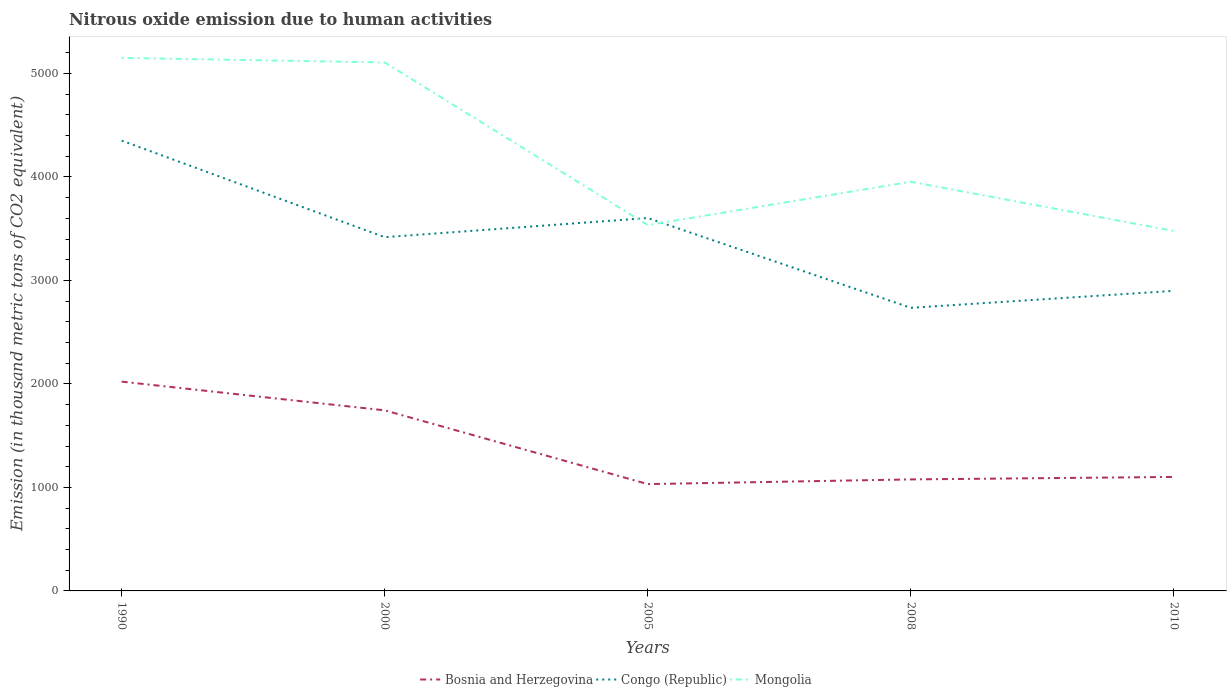How many different coloured lines are there?
Offer a very short reply. 3. Does the line corresponding to Bosnia and Herzegovina intersect with the line corresponding to Congo (Republic)?
Give a very brief answer. No. Is the number of lines equal to the number of legend labels?
Give a very brief answer. Yes. Across all years, what is the maximum amount of nitrous oxide emitted in Bosnia and Herzegovina?
Your answer should be compact. 1032.3. In which year was the amount of nitrous oxide emitted in Mongolia maximum?
Give a very brief answer. 2010. What is the total amount of nitrous oxide emitted in Bosnia and Herzegovina in the graph?
Ensure brevity in your answer.  712.6. What is the difference between the highest and the second highest amount of nitrous oxide emitted in Mongolia?
Your answer should be compact. 1672.8. Is the amount of nitrous oxide emitted in Bosnia and Herzegovina strictly greater than the amount of nitrous oxide emitted in Congo (Republic) over the years?
Offer a terse response. Yes. How many lines are there?
Your answer should be very brief. 3. How many years are there in the graph?
Make the answer very short. 5. What is the difference between two consecutive major ticks on the Y-axis?
Your answer should be compact. 1000. Does the graph contain grids?
Provide a short and direct response. No. What is the title of the graph?
Provide a succinct answer. Nitrous oxide emission due to human activities. What is the label or title of the X-axis?
Offer a terse response. Years. What is the label or title of the Y-axis?
Give a very brief answer. Emission (in thousand metric tons of CO2 equivalent). What is the Emission (in thousand metric tons of CO2 equivalent) in Bosnia and Herzegovina in 1990?
Offer a terse response. 2022.6. What is the Emission (in thousand metric tons of CO2 equivalent) in Congo (Republic) in 1990?
Keep it short and to the point. 4351.5. What is the Emission (in thousand metric tons of CO2 equivalent) in Mongolia in 1990?
Provide a short and direct response. 5151. What is the Emission (in thousand metric tons of CO2 equivalent) of Bosnia and Herzegovina in 2000?
Your answer should be very brief. 1744.9. What is the Emission (in thousand metric tons of CO2 equivalent) in Congo (Republic) in 2000?
Ensure brevity in your answer.  3418.3. What is the Emission (in thousand metric tons of CO2 equivalent) of Mongolia in 2000?
Give a very brief answer. 5106.8. What is the Emission (in thousand metric tons of CO2 equivalent) of Bosnia and Herzegovina in 2005?
Keep it short and to the point. 1032.3. What is the Emission (in thousand metric tons of CO2 equivalent) in Congo (Republic) in 2005?
Your answer should be compact. 3603.5. What is the Emission (in thousand metric tons of CO2 equivalent) in Mongolia in 2005?
Ensure brevity in your answer.  3535.4. What is the Emission (in thousand metric tons of CO2 equivalent) in Bosnia and Herzegovina in 2008?
Your answer should be compact. 1077.6. What is the Emission (in thousand metric tons of CO2 equivalent) in Congo (Republic) in 2008?
Offer a terse response. 2735.8. What is the Emission (in thousand metric tons of CO2 equivalent) in Mongolia in 2008?
Give a very brief answer. 3953.8. What is the Emission (in thousand metric tons of CO2 equivalent) of Bosnia and Herzegovina in 2010?
Keep it short and to the point. 1101.5. What is the Emission (in thousand metric tons of CO2 equivalent) of Congo (Republic) in 2010?
Give a very brief answer. 2899.8. What is the Emission (in thousand metric tons of CO2 equivalent) of Mongolia in 2010?
Your answer should be very brief. 3478.2. Across all years, what is the maximum Emission (in thousand metric tons of CO2 equivalent) of Bosnia and Herzegovina?
Provide a short and direct response. 2022.6. Across all years, what is the maximum Emission (in thousand metric tons of CO2 equivalent) in Congo (Republic)?
Your answer should be compact. 4351.5. Across all years, what is the maximum Emission (in thousand metric tons of CO2 equivalent) of Mongolia?
Your answer should be very brief. 5151. Across all years, what is the minimum Emission (in thousand metric tons of CO2 equivalent) in Bosnia and Herzegovina?
Offer a terse response. 1032.3. Across all years, what is the minimum Emission (in thousand metric tons of CO2 equivalent) in Congo (Republic)?
Your response must be concise. 2735.8. Across all years, what is the minimum Emission (in thousand metric tons of CO2 equivalent) of Mongolia?
Make the answer very short. 3478.2. What is the total Emission (in thousand metric tons of CO2 equivalent) of Bosnia and Herzegovina in the graph?
Make the answer very short. 6978.9. What is the total Emission (in thousand metric tons of CO2 equivalent) of Congo (Republic) in the graph?
Make the answer very short. 1.70e+04. What is the total Emission (in thousand metric tons of CO2 equivalent) of Mongolia in the graph?
Your answer should be very brief. 2.12e+04. What is the difference between the Emission (in thousand metric tons of CO2 equivalent) of Bosnia and Herzegovina in 1990 and that in 2000?
Provide a short and direct response. 277.7. What is the difference between the Emission (in thousand metric tons of CO2 equivalent) in Congo (Republic) in 1990 and that in 2000?
Your answer should be very brief. 933.2. What is the difference between the Emission (in thousand metric tons of CO2 equivalent) of Mongolia in 1990 and that in 2000?
Make the answer very short. 44.2. What is the difference between the Emission (in thousand metric tons of CO2 equivalent) of Bosnia and Herzegovina in 1990 and that in 2005?
Offer a very short reply. 990.3. What is the difference between the Emission (in thousand metric tons of CO2 equivalent) in Congo (Republic) in 1990 and that in 2005?
Offer a terse response. 748. What is the difference between the Emission (in thousand metric tons of CO2 equivalent) of Mongolia in 1990 and that in 2005?
Your answer should be compact. 1615.6. What is the difference between the Emission (in thousand metric tons of CO2 equivalent) of Bosnia and Herzegovina in 1990 and that in 2008?
Your answer should be very brief. 945. What is the difference between the Emission (in thousand metric tons of CO2 equivalent) in Congo (Republic) in 1990 and that in 2008?
Provide a short and direct response. 1615.7. What is the difference between the Emission (in thousand metric tons of CO2 equivalent) in Mongolia in 1990 and that in 2008?
Your response must be concise. 1197.2. What is the difference between the Emission (in thousand metric tons of CO2 equivalent) of Bosnia and Herzegovina in 1990 and that in 2010?
Provide a succinct answer. 921.1. What is the difference between the Emission (in thousand metric tons of CO2 equivalent) in Congo (Republic) in 1990 and that in 2010?
Your answer should be compact. 1451.7. What is the difference between the Emission (in thousand metric tons of CO2 equivalent) in Mongolia in 1990 and that in 2010?
Provide a succinct answer. 1672.8. What is the difference between the Emission (in thousand metric tons of CO2 equivalent) of Bosnia and Herzegovina in 2000 and that in 2005?
Give a very brief answer. 712.6. What is the difference between the Emission (in thousand metric tons of CO2 equivalent) of Congo (Republic) in 2000 and that in 2005?
Give a very brief answer. -185.2. What is the difference between the Emission (in thousand metric tons of CO2 equivalent) of Mongolia in 2000 and that in 2005?
Your answer should be very brief. 1571.4. What is the difference between the Emission (in thousand metric tons of CO2 equivalent) of Bosnia and Herzegovina in 2000 and that in 2008?
Offer a very short reply. 667.3. What is the difference between the Emission (in thousand metric tons of CO2 equivalent) of Congo (Republic) in 2000 and that in 2008?
Ensure brevity in your answer.  682.5. What is the difference between the Emission (in thousand metric tons of CO2 equivalent) of Mongolia in 2000 and that in 2008?
Your response must be concise. 1153. What is the difference between the Emission (in thousand metric tons of CO2 equivalent) of Bosnia and Herzegovina in 2000 and that in 2010?
Offer a very short reply. 643.4. What is the difference between the Emission (in thousand metric tons of CO2 equivalent) in Congo (Republic) in 2000 and that in 2010?
Give a very brief answer. 518.5. What is the difference between the Emission (in thousand metric tons of CO2 equivalent) in Mongolia in 2000 and that in 2010?
Your answer should be compact. 1628.6. What is the difference between the Emission (in thousand metric tons of CO2 equivalent) of Bosnia and Herzegovina in 2005 and that in 2008?
Keep it short and to the point. -45.3. What is the difference between the Emission (in thousand metric tons of CO2 equivalent) in Congo (Republic) in 2005 and that in 2008?
Your response must be concise. 867.7. What is the difference between the Emission (in thousand metric tons of CO2 equivalent) of Mongolia in 2005 and that in 2008?
Ensure brevity in your answer.  -418.4. What is the difference between the Emission (in thousand metric tons of CO2 equivalent) in Bosnia and Herzegovina in 2005 and that in 2010?
Give a very brief answer. -69.2. What is the difference between the Emission (in thousand metric tons of CO2 equivalent) in Congo (Republic) in 2005 and that in 2010?
Offer a terse response. 703.7. What is the difference between the Emission (in thousand metric tons of CO2 equivalent) in Mongolia in 2005 and that in 2010?
Give a very brief answer. 57.2. What is the difference between the Emission (in thousand metric tons of CO2 equivalent) in Bosnia and Herzegovina in 2008 and that in 2010?
Offer a terse response. -23.9. What is the difference between the Emission (in thousand metric tons of CO2 equivalent) of Congo (Republic) in 2008 and that in 2010?
Provide a succinct answer. -164. What is the difference between the Emission (in thousand metric tons of CO2 equivalent) of Mongolia in 2008 and that in 2010?
Keep it short and to the point. 475.6. What is the difference between the Emission (in thousand metric tons of CO2 equivalent) in Bosnia and Herzegovina in 1990 and the Emission (in thousand metric tons of CO2 equivalent) in Congo (Republic) in 2000?
Your response must be concise. -1395.7. What is the difference between the Emission (in thousand metric tons of CO2 equivalent) in Bosnia and Herzegovina in 1990 and the Emission (in thousand metric tons of CO2 equivalent) in Mongolia in 2000?
Ensure brevity in your answer.  -3084.2. What is the difference between the Emission (in thousand metric tons of CO2 equivalent) in Congo (Republic) in 1990 and the Emission (in thousand metric tons of CO2 equivalent) in Mongolia in 2000?
Ensure brevity in your answer.  -755.3. What is the difference between the Emission (in thousand metric tons of CO2 equivalent) of Bosnia and Herzegovina in 1990 and the Emission (in thousand metric tons of CO2 equivalent) of Congo (Republic) in 2005?
Your answer should be compact. -1580.9. What is the difference between the Emission (in thousand metric tons of CO2 equivalent) of Bosnia and Herzegovina in 1990 and the Emission (in thousand metric tons of CO2 equivalent) of Mongolia in 2005?
Make the answer very short. -1512.8. What is the difference between the Emission (in thousand metric tons of CO2 equivalent) in Congo (Republic) in 1990 and the Emission (in thousand metric tons of CO2 equivalent) in Mongolia in 2005?
Your answer should be compact. 816.1. What is the difference between the Emission (in thousand metric tons of CO2 equivalent) in Bosnia and Herzegovina in 1990 and the Emission (in thousand metric tons of CO2 equivalent) in Congo (Republic) in 2008?
Your answer should be very brief. -713.2. What is the difference between the Emission (in thousand metric tons of CO2 equivalent) of Bosnia and Herzegovina in 1990 and the Emission (in thousand metric tons of CO2 equivalent) of Mongolia in 2008?
Make the answer very short. -1931.2. What is the difference between the Emission (in thousand metric tons of CO2 equivalent) in Congo (Republic) in 1990 and the Emission (in thousand metric tons of CO2 equivalent) in Mongolia in 2008?
Offer a terse response. 397.7. What is the difference between the Emission (in thousand metric tons of CO2 equivalent) of Bosnia and Herzegovina in 1990 and the Emission (in thousand metric tons of CO2 equivalent) of Congo (Republic) in 2010?
Provide a short and direct response. -877.2. What is the difference between the Emission (in thousand metric tons of CO2 equivalent) of Bosnia and Herzegovina in 1990 and the Emission (in thousand metric tons of CO2 equivalent) of Mongolia in 2010?
Your response must be concise. -1455.6. What is the difference between the Emission (in thousand metric tons of CO2 equivalent) of Congo (Republic) in 1990 and the Emission (in thousand metric tons of CO2 equivalent) of Mongolia in 2010?
Your answer should be very brief. 873.3. What is the difference between the Emission (in thousand metric tons of CO2 equivalent) of Bosnia and Herzegovina in 2000 and the Emission (in thousand metric tons of CO2 equivalent) of Congo (Republic) in 2005?
Your answer should be very brief. -1858.6. What is the difference between the Emission (in thousand metric tons of CO2 equivalent) of Bosnia and Herzegovina in 2000 and the Emission (in thousand metric tons of CO2 equivalent) of Mongolia in 2005?
Your answer should be compact. -1790.5. What is the difference between the Emission (in thousand metric tons of CO2 equivalent) in Congo (Republic) in 2000 and the Emission (in thousand metric tons of CO2 equivalent) in Mongolia in 2005?
Offer a very short reply. -117.1. What is the difference between the Emission (in thousand metric tons of CO2 equivalent) of Bosnia and Herzegovina in 2000 and the Emission (in thousand metric tons of CO2 equivalent) of Congo (Republic) in 2008?
Offer a terse response. -990.9. What is the difference between the Emission (in thousand metric tons of CO2 equivalent) in Bosnia and Herzegovina in 2000 and the Emission (in thousand metric tons of CO2 equivalent) in Mongolia in 2008?
Provide a short and direct response. -2208.9. What is the difference between the Emission (in thousand metric tons of CO2 equivalent) of Congo (Republic) in 2000 and the Emission (in thousand metric tons of CO2 equivalent) of Mongolia in 2008?
Your answer should be compact. -535.5. What is the difference between the Emission (in thousand metric tons of CO2 equivalent) of Bosnia and Herzegovina in 2000 and the Emission (in thousand metric tons of CO2 equivalent) of Congo (Republic) in 2010?
Your response must be concise. -1154.9. What is the difference between the Emission (in thousand metric tons of CO2 equivalent) in Bosnia and Herzegovina in 2000 and the Emission (in thousand metric tons of CO2 equivalent) in Mongolia in 2010?
Offer a very short reply. -1733.3. What is the difference between the Emission (in thousand metric tons of CO2 equivalent) in Congo (Republic) in 2000 and the Emission (in thousand metric tons of CO2 equivalent) in Mongolia in 2010?
Give a very brief answer. -59.9. What is the difference between the Emission (in thousand metric tons of CO2 equivalent) of Bosnia and Herzegovina in 2005 and the Emission (in thousand metric tons of CO2 equivalent) of Congo (Republic) in 2008?
Give a very brief answer. -1703.5. What is the difference between the Emission (in thousand metric tons of CO2 equivalent) of Bosnia and Herzegovina in 2005 and the Emission (in thousand metric tons of CO2 equivalent) of Mongolia in 2008?
Keep it short and to the point. -2921.5. What is the difference between the Emission (in thousand metric tons of CO2 equivalent) in Congo (Republic) in 2005 and the Emission (in thousand metric tons of CO2 equivalent) in Mongolia in 2008?
Provide a short and direct response. -350.3. What is the difference between the Emission (in thousand metric tons of CO2 equivalent) of Bosnia and Herzegovina in 2005 and the Emission (in thousand metric tons of CO2 equivalent) of Congo (Republic) in 2010?
Keep it short and to the point. -1867.5. What is the difference between the Emission (in thousand metric tons of CO2 equivalent) in Bosnia and Herzegovina in 2005 and the Emission (in thousand metric tons of CO2 equivalent) in Mongolia in 2010?
Give a very brief answer. -2445.9. What is the difference between the Emission (in thousand metric tons of CO2 equivalent) in Congo (Republic) in 2005 and the Emission (in thousand metric tons of CO2 equivalent) in Mongolia in 2010?
Give a very brief answer. 125.3. What is the difference between the Emission (in thousand metric tons of CO2 equivalent) in Bosnia and Herzegovina in 2008 and the Emission (in thousand metric tons of CO2 equivalent) in Congo (Republic) in 2010?
Provide a succinct answer. -1822.2. What is the difference between the Emission (in thousand metric tons of CO2 equivalent) in Bosnia and Herzegovina in 2008 and the Emission (in thousand metric tons of CO2 equivalent) in Mongolia in 2010?
Give a very brief answer. -2400.6. What is the difference between the Emission (in thousand metric tons of CO2 equivalent) in Congo (Republic) in 2008 and the Emission (in thousand metric tons of CO2 equivalent) in Mongolia in 2010?
Provide a short and direct response. -742.4. What is the average Emission (in thousand metric tons of CO2 equivalent) in Bosnia and Herzegovina per year?
Keep it short and to the point. 1395.78. What is the average Emission (in thousand metric tons of CO2 equivalent) of Congo (Republic) per year?
Provide a succinct answer. 3401.78. What is the average Emission (in thousand metric tons of CO2 equivalent) of Mongolia per year?
Give a very brief answer. 4245.04. In the year 1990, what is the difference between the Emission (in thousand metric tons of CO2 equivalent) in Bosnia and Herzegovina and Emission (in thousand metric tons of CO2 equivalent) in Congo (Republic)?
Your response must be concise. -2328.9. In the year 1990, what is the difference between the Emission (in thousand metric tons of CO2 equivalent) in Bosnia and Herzegovina and Emission (in thousand metric tons of CO2 equivalent) in Mongolia?
Provide a short and direct response. -3128.4. In the year 1990, what is the difference between the Emission (in thousand metric tons of CO2 equivalent) in Congo (Republic) and Emission (in thousand metric tons of CO2 equivalent) in Mongolia?
Make the answer very short. -799.5. In the year 2000, what is the difference between the Emission (in thousand metric tons of CO2 equivalent) of Bosnia and Herzegovina and Emission (in thousand metric tons of CO2 equivalent) of Congo (Republic)?
Make the answer very short. -1673.4. In the year 2000, what is the difference between the Emission (in thousand metric tons of CO2 equivalent) in Bosnia and Herzegovina and Emission (in thousand metric tons of CO2 equivalent) in Mongolia?
Provide a short and direct response. -3361.9. In the year 2000, what is the difference between the Emission (in thousand metric tons of CO2 equivalent) in Congo (Republic) and Emission (in thousand metric tons of CO2 equivalent) in Mongolia?
Ensure brevity in your answer.  -1688.5. In the year 2005, what is the difference between the Emission (in thousand metric tons of CO2 equivalent) of Bosnia and Herzegovina and Emission (in thousand metric tons of CO2 equivalent) of Congo (Republic)?
Give a very brief answer. -2571.2. In the year 2005, what is the difference between the Emission (in thousand metric tons of CO2 equivalent) of Bosnia and Herzegovina and Emission (in thousand metric tons of CO2 equivalent) of Mongolia?
Keep it short and to the point. -2503.1. In the year 2005, what is the difference between the Emission (in thousand metric tons of CO2 equivalent) in Congo (Republic) and Emission (in thousand metric tons of CO2 equivalent) in Mongolia?
Offer a very short reply. 68.1. In the year 2008, what is the difference between the Emission (in thousand metric tons of CO2 equivalent) of Bosnia and Herzegovina and Emission (in thousand metric tons of CO2 equivalent) of Congo (Republic)?
Your answer should be compact. -1658.2. In the year 2008, what is the difference between the Emission (in thousand metric tons of CO2 equivalent) in Bosnia and Herzegovina and Emission (in thousand metric tons of CO2 equivalent) in Mongolia?
Offer a very short reply. -2876.2. In the year 2008, what is the difference between the Emission (in thousand metric tons of CO2 equivalent) of Congo (Republic) and Emission (in thousand metric tons of CO2 equivalent) of Mongolia?
Ensure brevity in your answer.  -1218. In the year 2010, what is the difference between the Emission (in thousand metric tons of CO2 equivalent) in Bosnia and Herzegovina and Emission (in thousand metric tons of CO2 equivalent) in Congo (Republic)?
Give a very brief answer. -1798.3. In the year 2010, what is the difference between the Emission (in thousand metric tons of CO2 equivalent) of Bosnia and Herzegovina and Emission (in thousand metric tons of CO2 equivalent) of Mongolia?
Your answer should be very brief. -2376.7. In the year 2010, what is the difference between the Emission (in thousand metric tons of CO2 equivalent) in Congo (Republic) and Emission (in thousand metric tons of CO2 equivalent) in Mongolia?
Give a very brief answer. -578.4. What is the ratio of the Emission (in thousand metric tons of CO2 equivalent) in Bosnia and Herzegovina in 1990 to that in 2000?
Your answer should be very brief. 1.16. What is the ratio of the Emission (in thousand metric tons of CO2 equivalent) in Congo (Republic) in 1990 to that in 2000?
Make the answer very short. 1.27. What is the ratio of the Emission (in thousand metric tons of CO2 equivalent) of Mongolia in 1990 to that in 2000?
Your answer should be very brief. 1.01. What is the ratio of the Emission (in thousand metric tons of CO2 equivalent) in Bosnia and Herzegovina in 1990 to that in 2005?
Your answer should be compact. 1.96. What is the ratio of the Emission (in thousand metric tons of CO2 equivalent) of Congo (Republic) in 1990 to that in 2005?
Make the answer very short. 1.21. What is the ratio of the Emission (in thousand metric tons of CO2 equivalent) in Mongolia in 1990 to that in 2005?
Your response must be concise. 1.46. What is the ratio of the Emission (in thousand metric tons of CO2 equivalent) in Bosnia and Herzegovina in 1990 to that in 2008?
Your response must be concise. 1.88. What is the ratio of the Emission (in thousand metric tons of CO2 equivalent) in Congo (Republic) in 1990 to that in 2008?
Provide a short and direct response. 1.59. What is the ratio of the Emission (in thousand metric tons of CO2 equivalent) in Mongolia in 1990 to that in 2008?
Provide a short and direct response. 1.3. What is the ratio of the Emission (in thousand metric tons of CO2 equivalent) in Bosnia and Herzegovina in 1990 to that in 2010?
Make the answer very short. 1.84. What is the ratio of the Emission (in thousand metric tons of CO2 equivalent) of Congo (Republic) in 1990 to that in 2010?
Offer a very short reply. 1.5. What is the ratio of the Emission (in thousand metric tons of CO2 equivalent) of Mongolia in 1990 to that in 2010?
Your answer should be compact. 1.48. What is the ratio of the Emission (in thousand metric tons of CO2 equivalent) of Bosnia and Herzegovina in 2000 to that in 2005?
Ensure brevity in your answer.  1.69. What is the ratio of the Emission (in thousand metric tons of CO2 equivalent) of Congo (Republic) in 2000 to that in 2005?
Ensure brevity in your answer.  0.95. What is the ratio of the Emission (in thousand metric tons of CO2 equivalent) of Mongolia in 2000 to that in 2005?
Ensure brevity in your answer.  1.44. What is the ratio of the Emission (in thousand metric tons of CO2 equivalent) of Bosnia and Herzegovina in 2000 to that in 2008?
Make the answer very short. 1.62. What is the ratio of the Emission (in thousand metric tons of CO2 equivalent) of Congo (Republic) in 2000 to that in 2008?
Provide a short and direct response. 1.25. What is the ratio of the Emission (in thousand metric tons of CO2 equivalent) in Mongolia in 2000 to that in 2008?
Ensure brevity in your answer.  1.29. What is the ratio of the Emission (in thousand metric tons of CO2 equivalent) of Bosnia and Herzegovina in 2000 to that in 2010?
Your response must be concise. 1.58. What is the ratio of the Emission (in thousand metric tons of CO2 equivalent) of Congo (Republic) in 2000 to that in 2010?
Offer a very short reply. 1.18. What is the ratio of the Emission (in thousand metric tons of CO2 equivalent) in Mongolia in 2000 to that in 2010?
Your response must be concise. 1.47. What is the ratio of the Emission (in thousand metric tons of CO2 equivalent) in Bosnia and Herzegovina in 2005 to that in 2008?
Your response must be concise. 0.96. What is the ratio of the Emission (in thousand metric tons of CO2 equivalent) of Congo (Republic) in 2005 to that in 2008?
Keep it short and to the point. 1.32. What is the ratio of the Emission (in thousand metric tons of CO2 equivalent) of Mongolia in 2005 to that in 2008?
Your response must be concise. 0.89. What is the ratio of the Emission (in thousand metric tons of CO2 equivalent) in Bosnia and Herzegovina in 2005 to that in 2010?
Make the answer very short. 0.94. What is the ratio of the Emission (in thousand metric tons of CO2 equivalent) of Congo (Republic) in 2005 to that in 2010?
Offer a very short reply. 1.24. What is the ratio of the Emission (in thousand metric tons of CO2 equivalent) in Mongolia in 2005 to that in 2010?
Provide a short and direct response. 1.02. What is the ratio of the Emission (in thousand metric tons of CO2 equivalent) of Bosnia and Herzegovina in 2008 to that in 2010?
Keep it short and to the point. 0.98. What is the ratio of the Emission (in thousand metric tons of CO2 equivalent) of Congo (Republic) in 2008 to that in 2010?
Ensure brevity in your answer.  0.94. What is the ratio of the Emission (in thousand metric tons of CO2 equivalent) of Mongolia in 2008 to that in 2010?
Give a very brief answer. 1.14. What is the difference between the highest and the second highest Emission (in thousand metric tons of CO2 equivalent) in Bosnia and Herzegovina?
Offer a very short reply. 277.7. What is the difference between the highest and the second highest Emission (in thousand metric tons of CO2 equivalent) in Congo (Republic)?
Make the answer very short. 748. What is the difference between the highest and the second highest Emission (in thousand metric tons of CO2 equivalent) of Mongolia?
Provide a succinct answer. 44.2. What is the difference between the highest and the lowest Emission (in thousand metric tons of CO2 equivalent) of Bosnia and Herzegovina?
Ensure brevity in your answer.  990.3. What is the difference between the highest and the lowest Emission (in thousand metric tons of CO2 equivalent) of Congo (Republic)?
Give a very brief answer. 1615.7. What is the difference between the highest and the lowest Emission (in thousand metric tons of CO2 equivalent) in Mongolia?
Provide a short and direct response. 1672.8. 